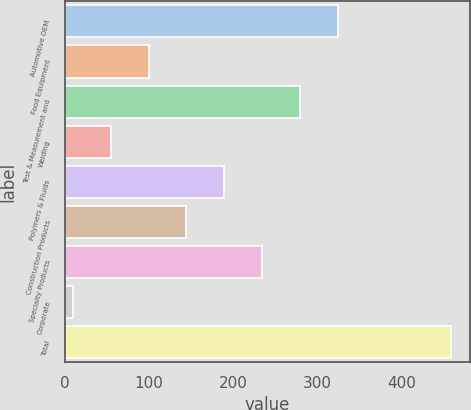Convert chart. <chart><loc_0><loc_0><loc_500><loc_500><bar_chart><fcel>Automotive OEM<fcel>Food Equipment<fcel>Test & Measurement and<fcel>Welding<fcel>Polymers & Fluids<fcel>Construction Products<fcel>Specialty Products<fcel>Corporate<fcel>Total<nl><fcel>324.3<fcel>99.8<fcel>279.4<fcel>54.9<fcel>189.6<fcel>144.7<fcel>234.5<fcel>10<fcel>459<nl></chart> 